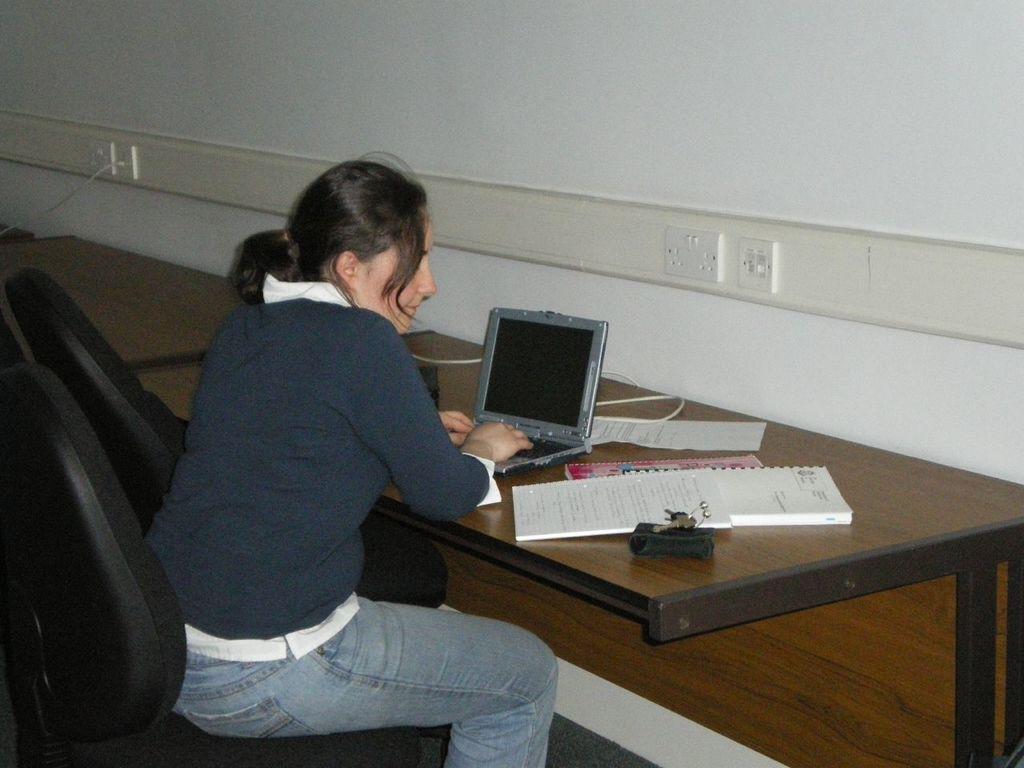In one or two sentences, can you explain what this image depicts? In this image we can see there is a lady sitting in front of the table and operating laptop, also there are so many books beside the laptop. 